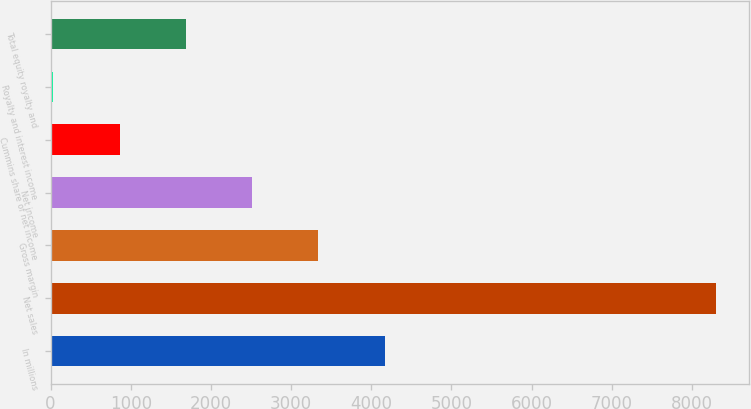Convert chart. <chart><loc_0><loc_0><loc_500><loc_500><bar_chart><fcel>In millions<fcel>Net sales<fcel>Gross margin<fcel>Net income<fcel>Cummins share of net income<fcel>Royalty and interest income<fcel>Total equity royalty and<nl><fcel>4166.5<fcel>8296<fcel>3340.6<fcel>2514.7<fcel>862.9<fcel>37<fcel>1688.8<nl></chart> 